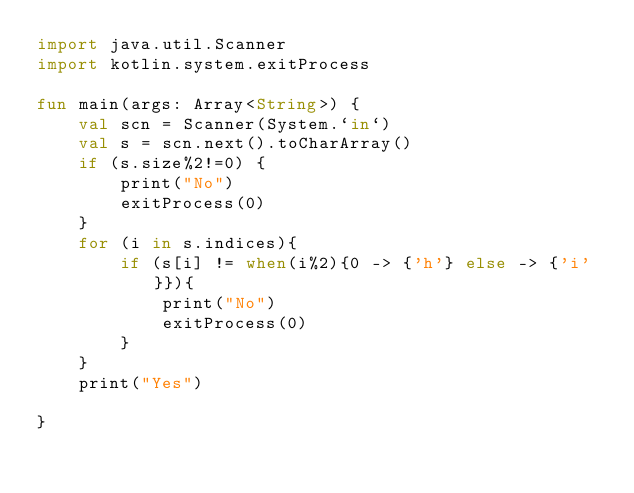<code> <loc_0><loc_0><loc_500><loc_500><_Kotlin_>import java.util.Scanner
import kotlin.system.exitProcess

fun main(args: Array<String>) {
	val scn = Scanner(System.`in`)
	val s = scn.next().toCharArray()
	if (s.size%2!=0) {
		print("No")
		exitProcess(0)
	}
	for (i in s.indices){
		if (s[i] != when(i%2){0 -> {'h'} else -> {'i'}}){
			print("No")
			exitProcess(0)
		}
	}
	print("Yes")

}</code> 